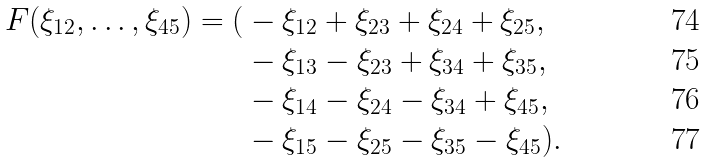<formula> <loc_0><loc_0><loc_500><loc_500>\ F ( \xi _ { 1 2 } , \dots , \xi _ { 4 5 } ) = ( & - \xi _ { 1 2 } + \xi _ { 2 3 } + \xi _ { 2 4 } + \xi _ { 2 5 } , \\ & - \xi _ { 1 3 } - \xi _ { 2 3 } + \xi _ { 3 4 } + \xi _ { 3 5 } , \\ & - \xi _ { 1 4 } - \xi _ { 2 4 } - \xi _ { 3 4 } + \xi _ { 4 5 } , \\ & - \xi _ { 1 5 } - \xi _ { 2 5 } - \xi _ { 3 5 } - \xi _ { 4 5 } ) .</formula> 